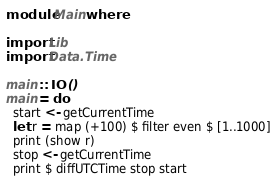Convert code to text. <code><loc_0><loc_0><loc_500><loc_500><_Haskell_>module Main where

import Lib
import Data.Time

main :: IO ()
main = do
  start <- getCurrentTime
  let r = map (+100) $ filter even $ [1..1000]
  print (show r)
  stop <- getCurrentTime
  print $ diffUTCTime stop start
</code> 